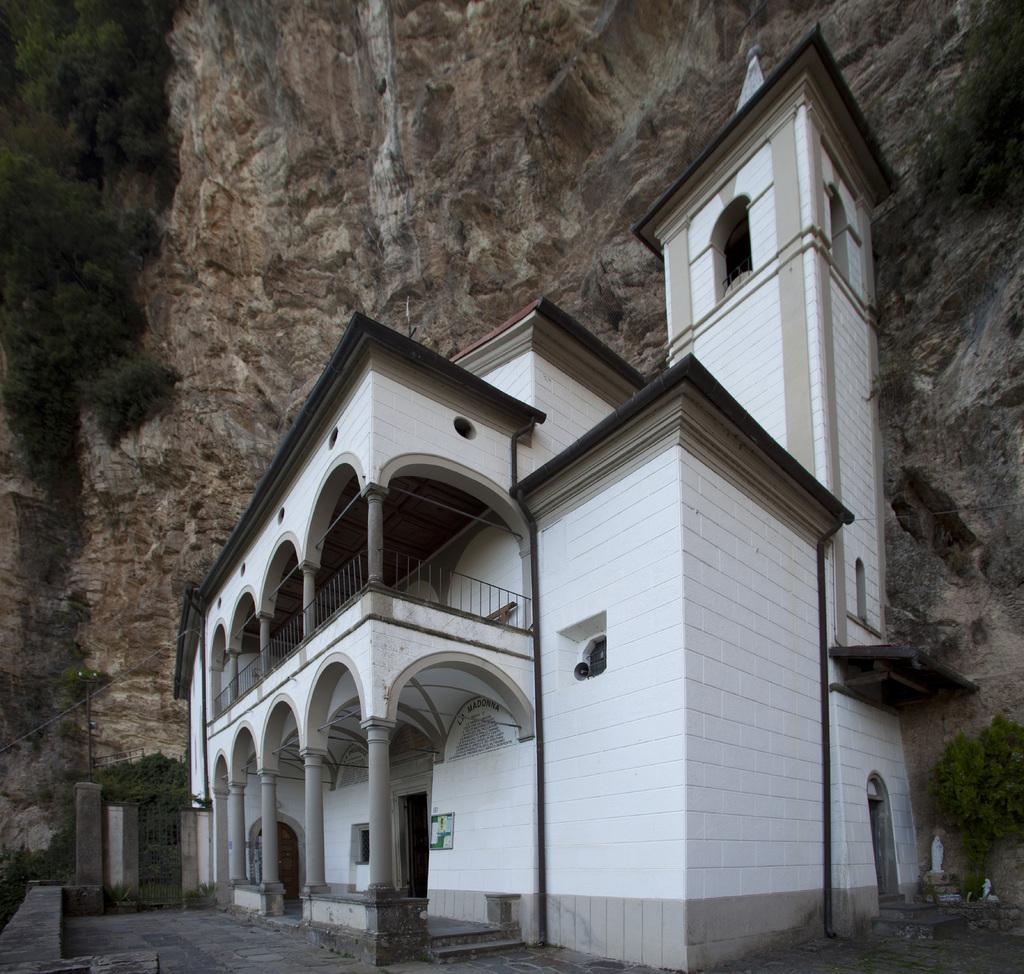What type of structure is visible in the image? There is a building in the image. What colors are present on the building? The building has white and brown colors. What can be seen in the background of the image? There are plants, trees, and a rock in the background of the image. What color are the plants and trees in the background? The plants and trees have a green color. What color is the rock in the background? The rock has a brown color. What type of stove can be seen in the image? There is no stove present in the image. Is the plane visible in the image? There is no plane present in the image. 